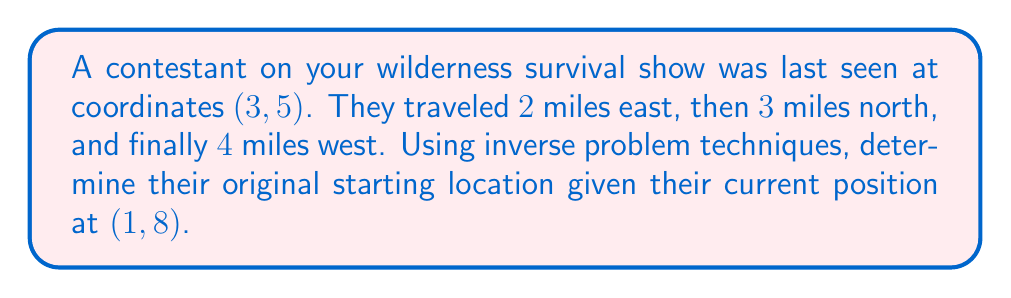Solve this math problem. To solve this inverse problem, we need to work backward from the contestant's current position to their original starting point. Let's approach this step-by-step:

1) Current position: (1, 8)

2) Reverse the last movement:
   4 miles west = 4 miles east
   New position: (1 + 4, 8) = (5, 8)

3) Reverse the second movement:
   3 miles north = 3 miles south
   New position: (5, 8 - 3) = (5, 5)

4) Reverse the first movement:
   2 miles east = 2 miles west
   New position: (5 - 2, 5) = (3, 5)

5) Check:
   Let $(x, y)$ be the original position.
   $x + 2 - 4 = 1$
   $y + 3 = 8$
   
   Solving these equations:
   $x = 3$
   $y = 5$

Therefore, the original starting location was (3, 5), which matches the given information in the question.

To visualize this:

[asy]
unitsize(1cm);
draw((-1,-1)--(6,9), gray);
draw((-1,0)--(6,0), arrow=Arrow(TeXHead));
draw((0,-1)--(0,9), arrow=Arrow(TeXHead));
label("x", (6,0), E);
label("y", (0,9), N);
dot((3,5));
dot((5,5));
dot((5,8));
dot((1,8));
label("Start (3,5)", (3,5), SW);
label("(5,5)", (5,5), SE);
label("(5,8)", (5,8), NE);
label("End (1,8)", (1,8), NW);
draw((3,5)--(5,5)--(5,8)--(1,8), arrow=Arrow(TeXHead));
label("2E", (4,5), S);
label("3N", (5,6.5), E);
label("4W", (3,8), N);
[/asy]
Answer: (3, 5) 